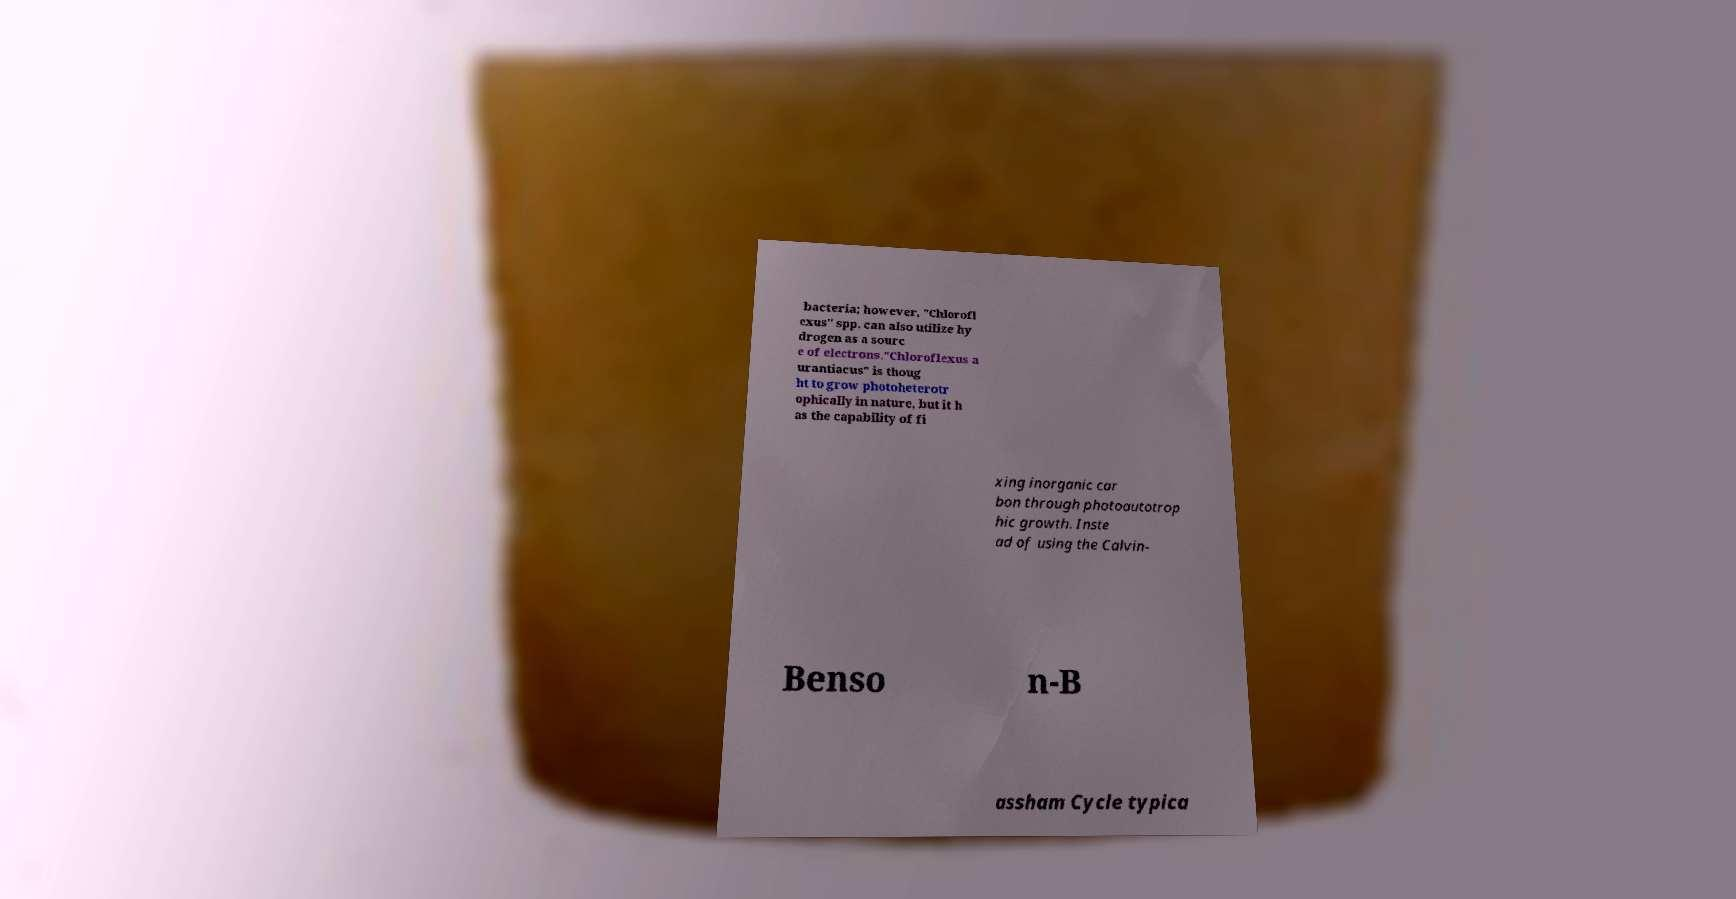What messages or text are displayed in this image? I need them in a readable, typed format. bacteria; however, "Chlorofl exus" spp. can also utilize hy drogen as a sourc e of electrons."Chloroflexus a urantiacus" is thoug ht to grow photoheterotr ophically in nature, but it h as the capability of fi xing inorganic car bon through photoautotrop hic growth. Inste ad of using the Calvin- Benso n-B assham Cycle typica 